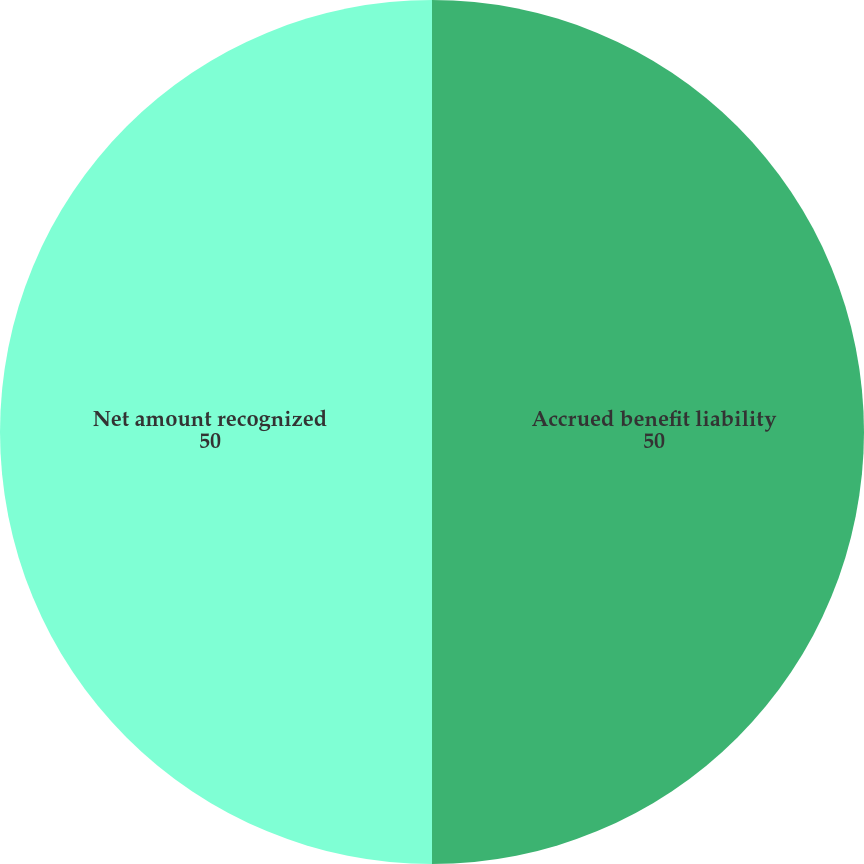<chart> <loc_0><loc_0><loc_500><loc_500><pie_chart><fcel>Accrued benefit liability<fcel>Net amount recognized<nl><fcel>50.0%<fcel>50.0%<nl></chart> 